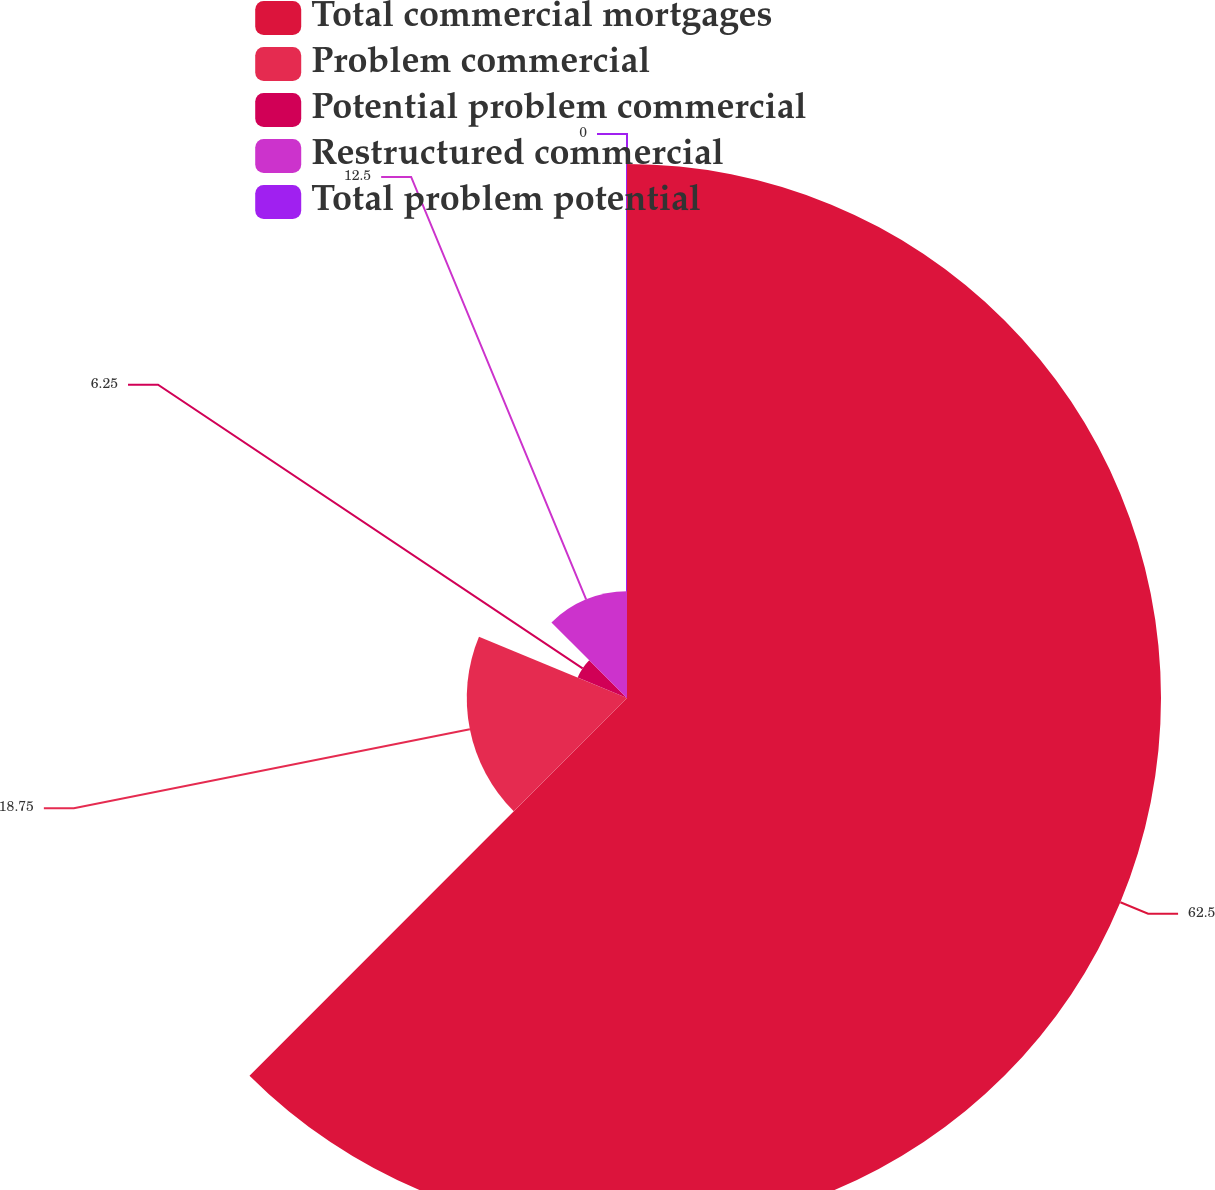<chart> <loc_0><loc_0><loc_500><loc_500><pie_chart><fcel>Total commercial mortgages<fcel>Problem commercial<fcel>Potential problem commercial<fcel>Restructured commercial<fcel>Total problem potential<nl><fcel>62.49%<fcel>18.75%<fcel>6.25%<fcel>12.5%<fcel>0.0%<nl></chart> 